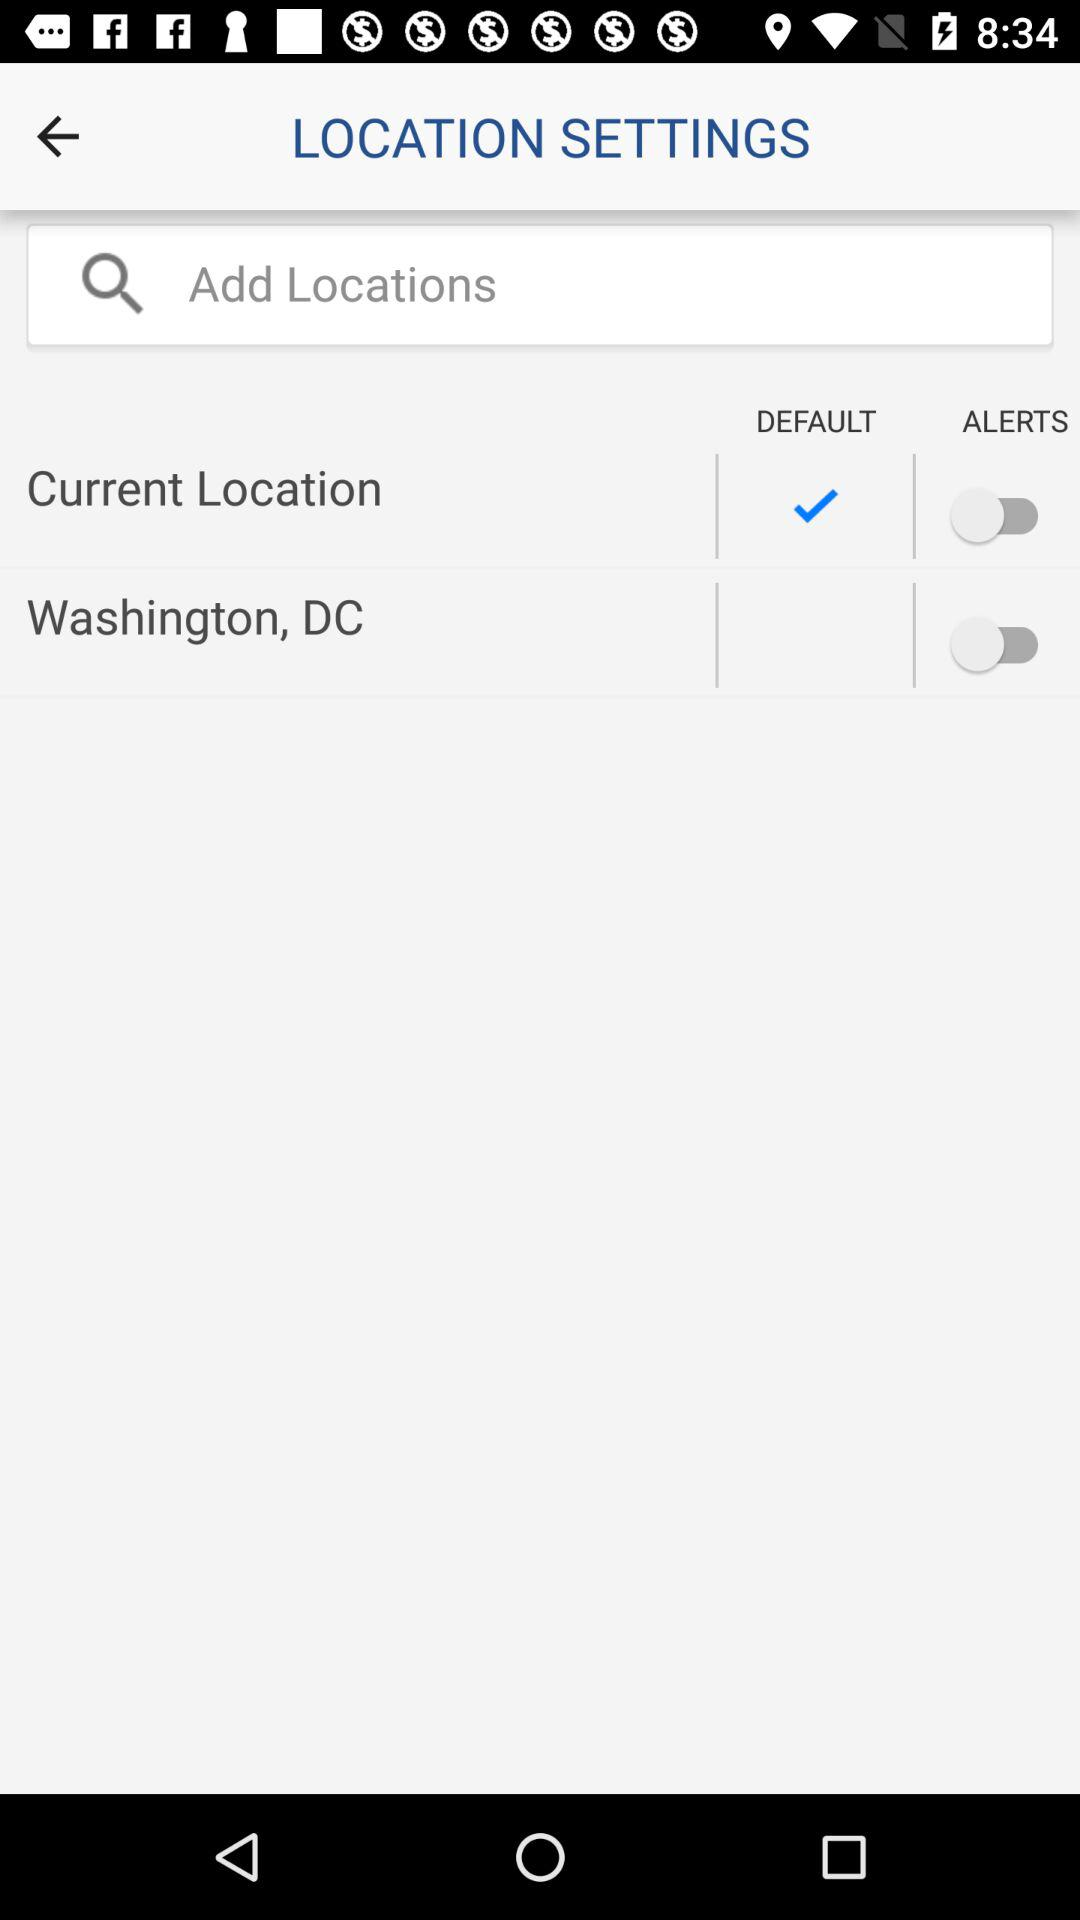What option is selected as the default? The selected option is "Current Location". 